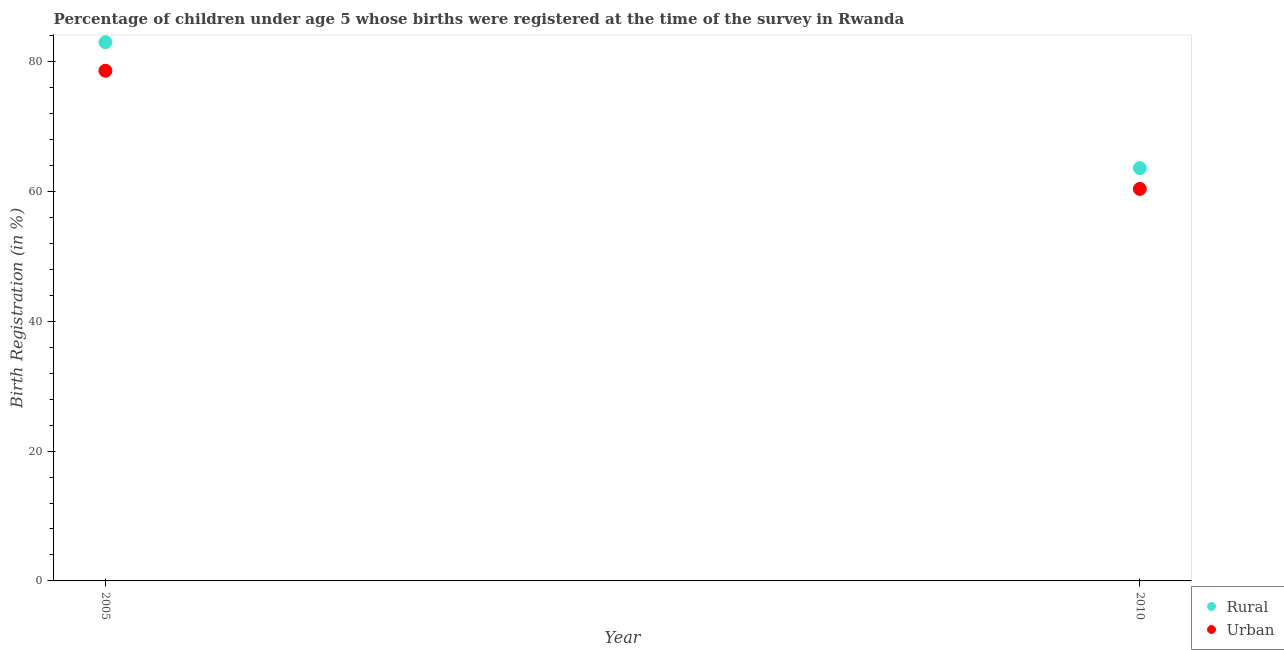What is the rural birth registration in 2005?
Provide a short and direct response. 83. Across all years, what is the maximum urban birth registration?
Offer a very short reply. 78.6. Across all years, what is the minimum rural birth registration?
Give a very brief answer. 63.6. In which year was the rural birth registration maximum?
Provide a succinct answer. 2005. What is the total urban birth registration in the graph?
Offer a very short reply. 139. What is the difference between the rural birth registration in 2005 and that in 2010?
Ensure brevity in your answer.  19.4. What is the difference between the urban birth registration in 2010 and the rural birth registration in 2005?
Make the answer very short. -22.6. What is the average urban birth registration per year?
Keep it short and to the point. 69.5. In the year 2010, what is the difference between the rural birth registration and urban birth registration?
Your answer should be compact. 3.2. What is the ratio of the urban birth registration in 2005 to that in 2010?
Make the answer very short. 1.3. Is the urban birth registration in 2005 less than that in 2010?
Ensure brevity in your answer.  No. In how many years, is the rural birth registration greater than the average rural birth registration taken over all years?
Give a very brief answer. 1. Does the rural birth registration monotonically increase over the years?
Offer a very short reply. No. How many years are there in the graph?
Keep it short and to the point. 2. What is the difference between two consecutive major ticks on the Y-axis?
Give a very brief answer. 20. Are the values on the major ticks of Y-axis written in scientific E-notation?
Make the answer very short. No. Does the graph contain any zero values?
Provide a short and direct response. No. How are the legend labels stacked?
Your answer should be compact. Vertical. What is the title of the graph?
Keep it short and to the point. Percentage of children under age 5 whose births were registered at the time of the survey in Rwanda. Does "Male entrants" appear as one of the legend labels in the graph?
Provide a succinct answer. No. What is the label or title of the Y-axis?
Offer a terse response. Birth Registration (in %). What is the Birth Registration (in %) in Urban in 2005?
Your answer should be very brief. 78.6. What is the Birth Registration (in %) in Rural in 2010?
Ensure brevity in your answer.  63.6. What is the Birth Registration (in %) of Urban in 2010?
Offer a very short reply. 60.4. Across all years, what is the maximum Birth Registration (in %) in Rural?
Offer a very short reply. 83. Across all years, what is the maximum Birth Registration (in %) in Urban?
Your answer should be compact. 78.6. Across all years, what is the minimum Birth Registration (in %) of Rural?
Give a very brief answer. 63.6. Across all years, what is the minimum Birth Registration (in %) of Urban?
Keep it short and to the point. 60.4. What is the total Birth Registration (in %) in Rural in the graph?
Provide a succinct answer. 146.6. What is the total Birth Registration (in %) of Urban in the graph?
Your answer should be compact. 139. What is the difference between the Birth Registration (in %) of Rural in 2005 and that in 2010?
Your answer should be compact. 19.4. What is the difference between the Birth Registration (in %) of Rural in 2005 and the Birth Registration (in %) of Urban in 2010?
Ensure brevity in your answer.  22.6. What is the average Birth Registration (in %) of Rural per year?
Provide a short and direct response. 73.3. What is the average Birth Registration (in %) in Urban per year?
Offer a terse response. 69.5. In the year 2005, what is the difference between the Birth Registration (in %) in Rural and Birth Registration (in %) in Urban?
Keep it short and to the point. 4.4. What is the ratio of the Birth Registration (in %) in Rural in 2005 to that in 2010?
Ensure brevity in your answer.  1.3. What is the ratio of the Birth Registration (in %) of Urban in 2005 to that in 2010?
Keep it short and to the point. 1.3. What is the difference between the highest and the lowest Birth Registration (in %) of Rural?
Your answer should be very brief. 19.4. 